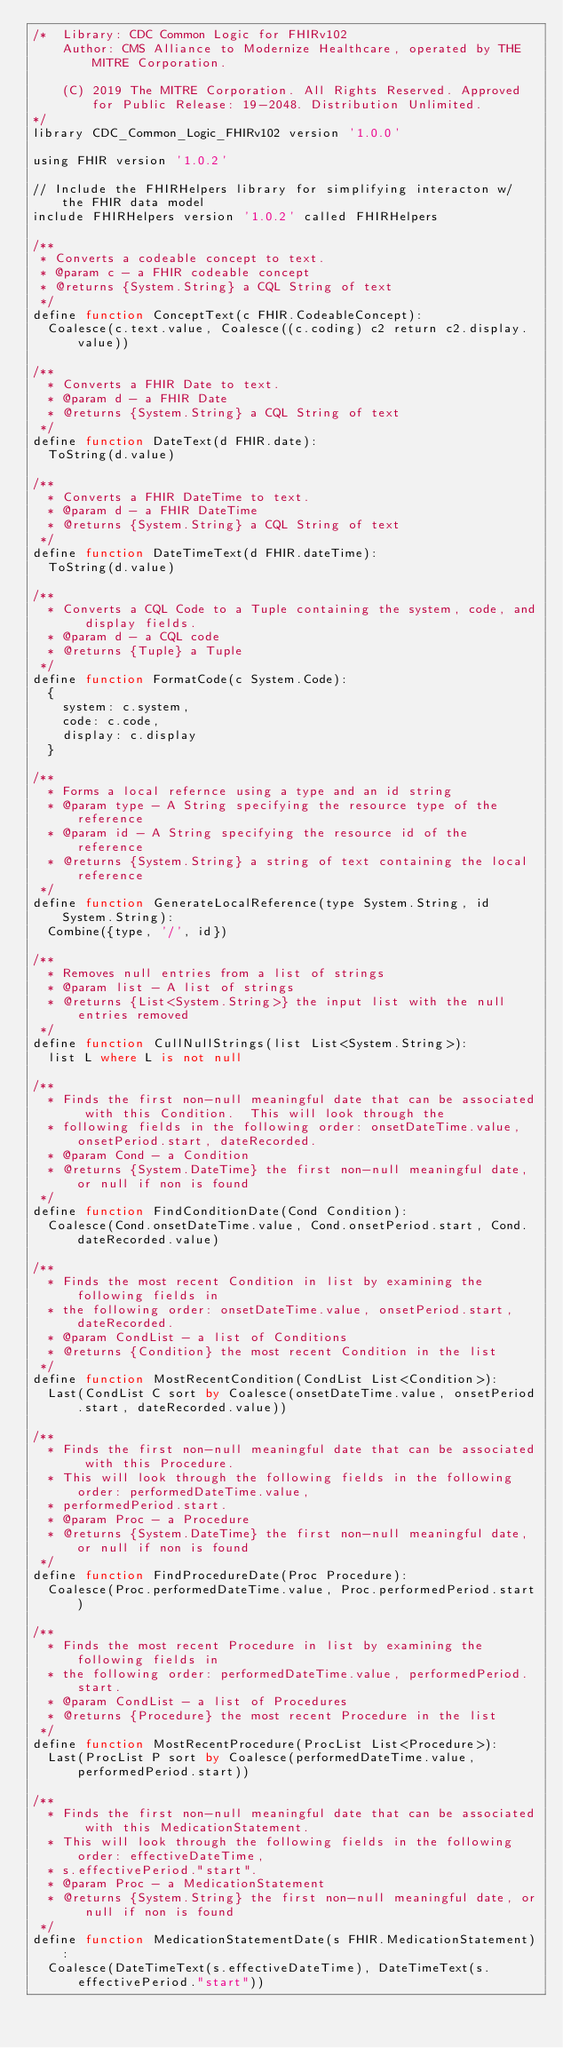Convert code to text. <code><loc_0><loc_0><loc_500><loc_500><_SQL_>/*  Library: CDC Common Logic for FHIRv102
    Author: CMS Alliance to Modernize Healthcare, operated by THE MITRE Corporation.

    (C) 2019 The MITRE Corporation. All Rights Reserved. Approved for Public Release: 19-2048. Distribution Unlimited.
*/
library CDC_Common_Logic_FHIRv102 version '1.0.0'

using FHIR version '1.0.2'

// Include the FHIRHelpers library for simplifying interacton w/ the FHIR data model
include FHIRHelpers version '1.0.2' called FHIRHelpers

/**
 * Converts a codeable concept to text.
 * @param c - a FHIR codeable concept
 * @returns {System.String} a CQL String of text
 */
define function ConceptText(c FHIR.CodeableConcept):
  Coalesce(c.text.value, Coalesce((c.coding) c2 return c2.display.value))

/**
  * Converts a FHIR Date to text.
  * @param d - a FHIR Date
  * @returns {System.String} a CQL String of text
 */
define function DateText(d FHIR.date):
  ToString(d.value)

/**
  * Converts a FHIR DateTime to text.
  * @param d - a FHIR DateTime
  * @returns {System.String} a CQL String of text
 */
define function DateTimeText(d FHIR.dateTime):
  ToString(d.value)

/**
  * Converts a CQL Code to a Tuple containing the system, code, and display fields.
  * @param d - a CQL code
  * @returns {Tuple} a Tuple
 */
define function FormatCode(c System.Code):
  {
    system: c.system,
    code: c.code,
    display: c.display
  }

/**
  * Forms a local refernce using a type and an id string
  * @param type - A String specifying the resource type of the reference
  * @param id - A String specifying the resource id of the reference
  * @returns {System.String} a string of text containing the local reference
 */
define function GenerateLocalReference(type System.String, id System.String):
  Combine({type, '/', id})

/**
  * Removes null entries from a list of strings
  * @param list - A list of strings
  * @returns {List<System.String>} the input list with the null entries removed
 */
define function CullNullStrings(list List<System.String>):
  list L where L is not null

/**
  * Finds the first non-null meaningful date that can be associated with this Condition.  This will look through the
  * following fields in the following order: onsetDateTime.value, onsetPeriod.start, dateRecorded.
  * @param Cond - a Condition
  * @returns {System.DateTime} the first non-null meaningful date, or null if non is found
 */
define function FindConditionDate(Cond Condition):
  Coalesce(Cond.onsetDateTime.value, Cond.onsetPeriod.start, Cond.dateRecorded.value)

/**
  * Finds the most recent Condition in list by examining the following fields in
  * the following order: onsetDateTime.value, onsetPeriod.start, dateRecorded.
  * @param CondList - a list of Conditions
  * @returns {Condition} the most recent Condition in the list
 */
define function MostRecentCondition(CondList List<Condition>):
  Last(CondList C sort by Coalesce(onsetDateTime.value, onsetPeriod.start, dateRecorded.value))

/**
  * Finds the first non-null meaningful date that can be associated with this Procedure.
  * This will look through the following fields in the following order: performedDateTime.value,
  * performedPeriod.start.
  * @param Proc - a Procedure
  * @returns {System.DateTime} the first non-null meaningful date, or null if non is found
 */
define function FindProcedureDate(Proc Procedure):
  Coalesce(Proc.performedDateTime.value, Proc.performedPeriod.start)

/**
  * Finds the most recent Procedure in list by examining the following fields in
  * the following order: performedDateTime.value, performedPeriod.start.
  * @param CondList - a list of Procedures
  * @returns {Procedure} the most recent Procedure in the list
 */
define function MostRecentProcedure(ProcList List<Procedure>):
  Last(ProcList P sort by Coalesce(performedDateTime.value, performedPeriod.start))

/**
  * Finds the first non-null meaningful date that can be associated with this MedicationStatement.
  * This will look through the following fields in the following order: effectiveDateTime,
  * s.effectivePeriod."start".
  * @param Proc - a MedicationStatement
  * @returns {System.String} the first non-null meaningful date, or null if non is found
 */
define function MedicationStatementDate(s FHIR.MedicationStatement):
  Coalesce(DateTimeText(s.effectiveDateTime), DateTimeText(s.effectivePeriod."start"))
</code> 